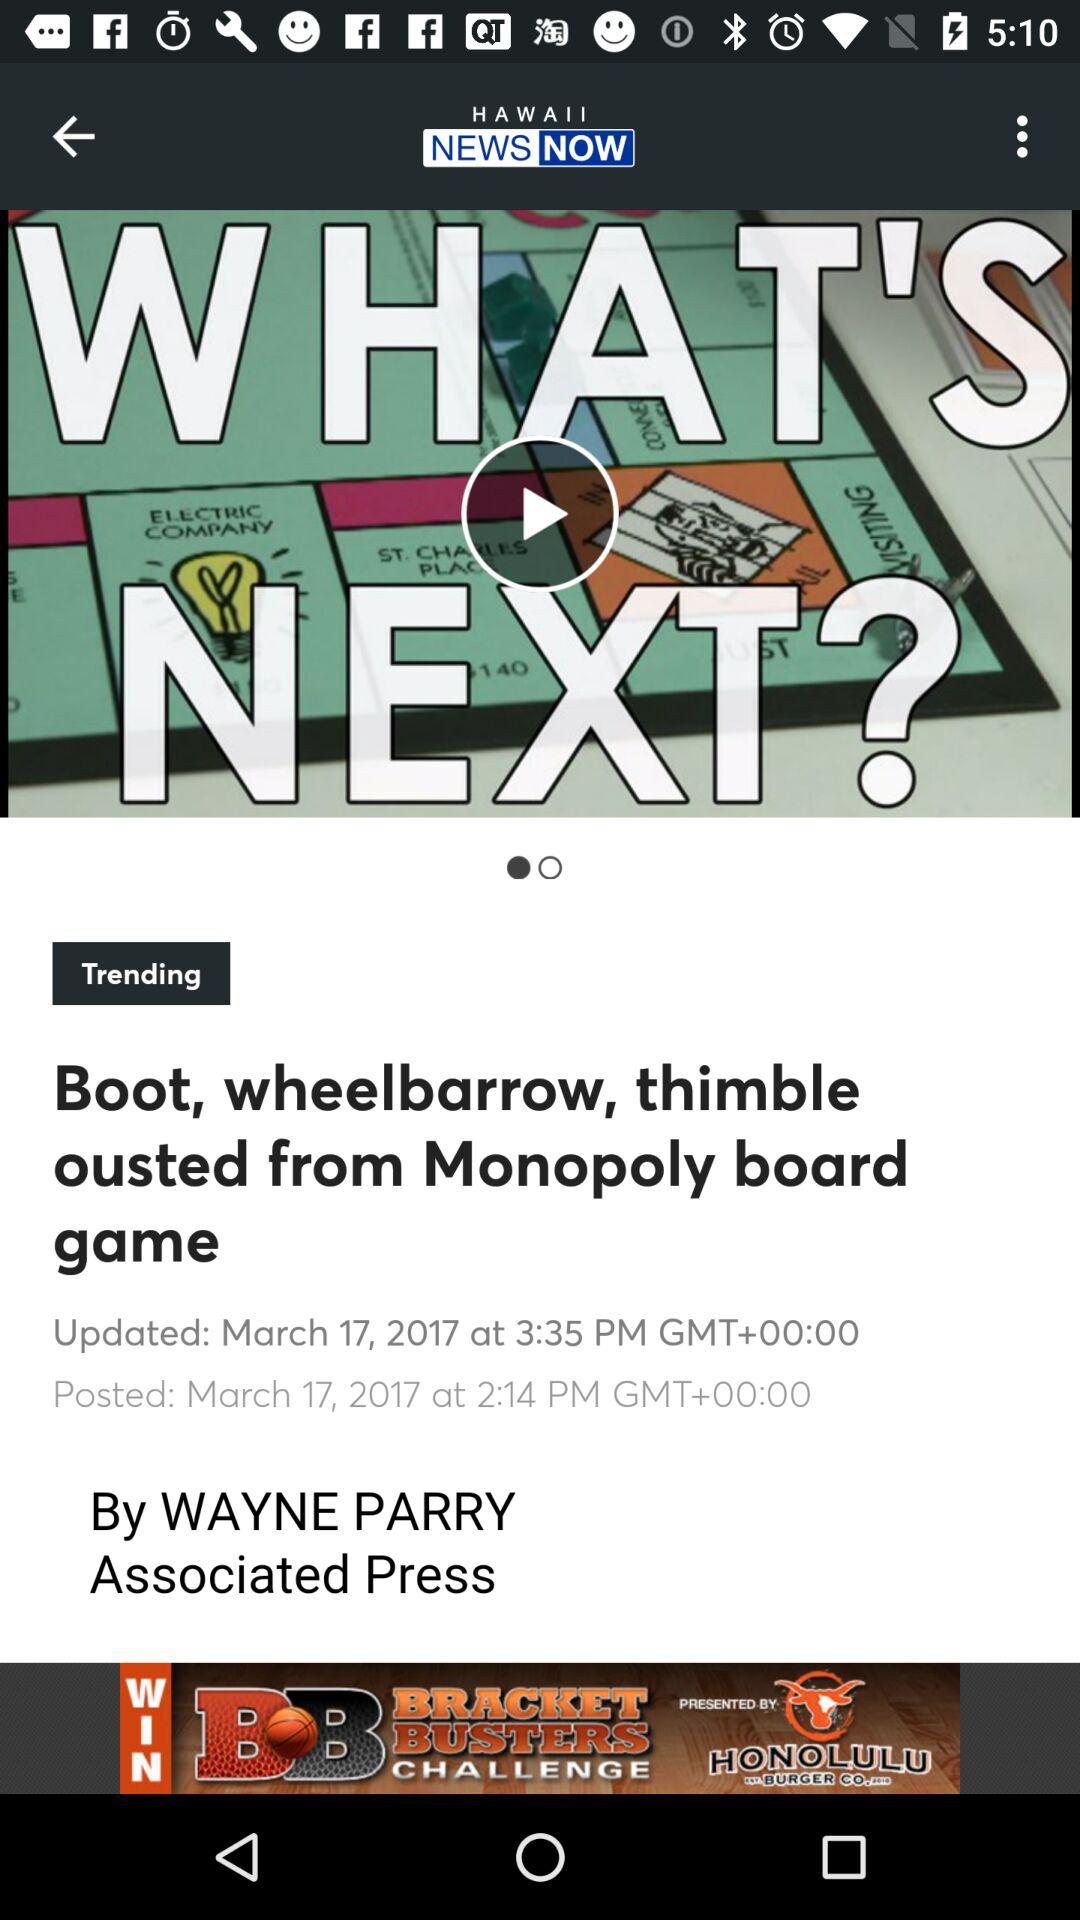What is the app name? The app name is "HAWAII NEWS NOW". 